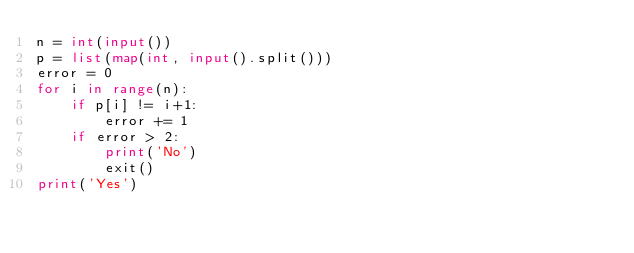<code> <loc_0><loc_0><loc_500><loc_500><_Python_>n = int(input())
p = list(map(int, input().split()))
error = 0
for i in range(n):
    if p[i] != i+1:
        error += 1
    if error > 2:
        print('No')
        exit()
print('Yes')
</code> 